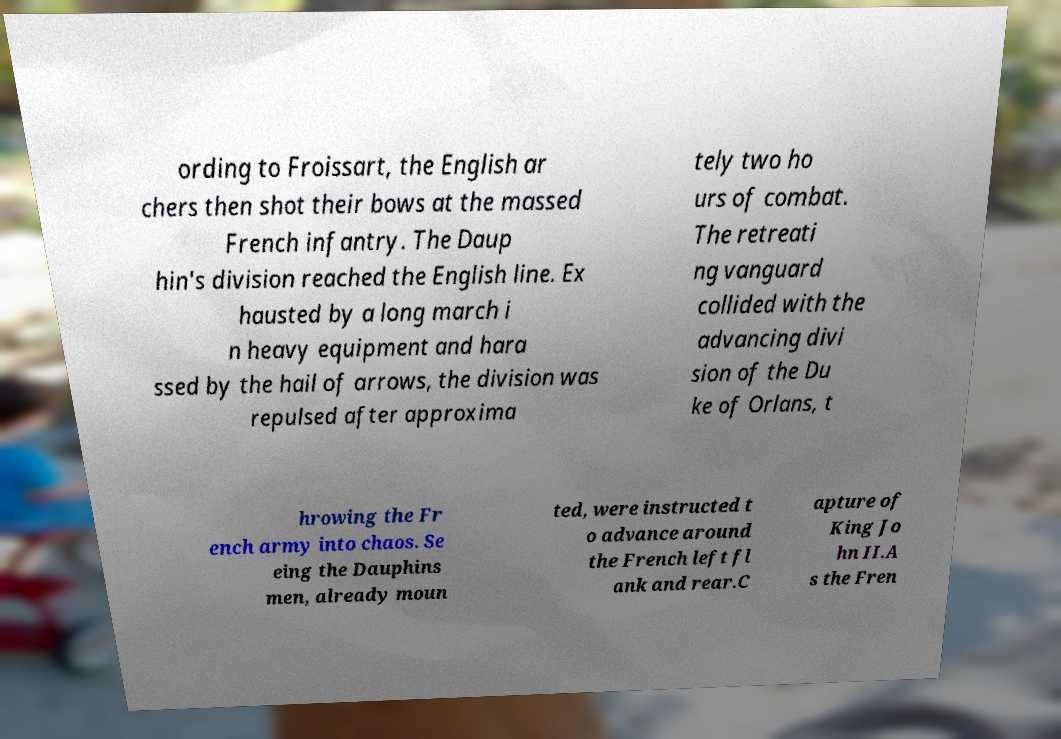Please read and relay the text visible in this image. What does it say? ording to Froissart, the English ar chers then shot their bows at the massed French infantry. The Daup hin's division reached the English line. Ex hausted by a long march i n heavy equipment and hara ssed by the hail of arrows, the division was repulsed after approxima tely two ho urs of combat. The retreati ng vanguard collided with the advancing divi sion of the Du ke of Orlans, t hrowing the Fr ench army into chaos. Se eing the Dauphins men, already moun ted, were instructed t o advance around the French left fl ank and rear.C apture of King Jo hn II.A s the Fren 